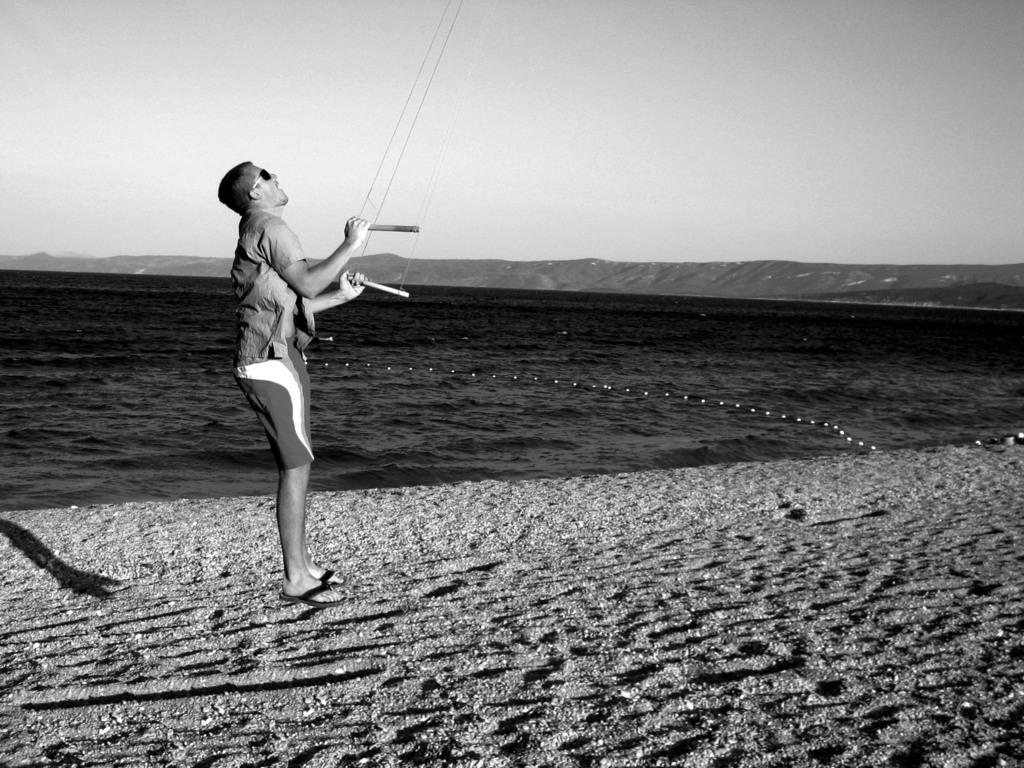Who is present in the image? There is a man in the image. What is the man holding in the image? The man is holding ropes in the image. What type of terrain is visible at the bottom of the image? There is sand at the bottom of the image. What can be seen in the background of the image? There is water, hills, and the sky visible in the background of the image. What type of stamp can be seen on the man's forehead in the image? There is no stamp visible on the man's forehead in the image. Who is the father of the man in the image? The provided facts do not mention the man's father, so it cannot be determined from the image. 